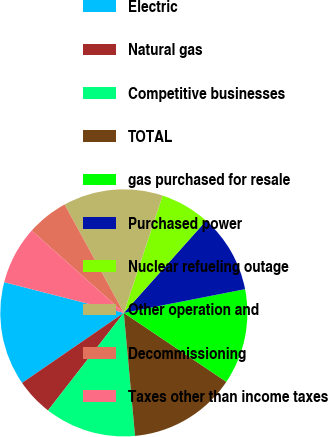<chart> <loc_0><loc_0><loc_500><loc_500><pie_chart><fcel>Electric<fcel>Natural gas<fcel>Competitive businesses<fcel>TOTAL<fcel>gas purchased for resale<fcel>Purchased power<fcel>Nuclear refueling outage<fcel>Other operation and<fcel>Decommissioning<fcel>Taxes other than income taxes<nl><fcel>13.59%<fcel>4.89%<fcel>11.96%<fcel>14.13%<fcel>12.5%<fcel>10.33%<fcel>6.52%<fcel>13.04%<fcel>5.43%<fcel>7.61%<nl></chart> 